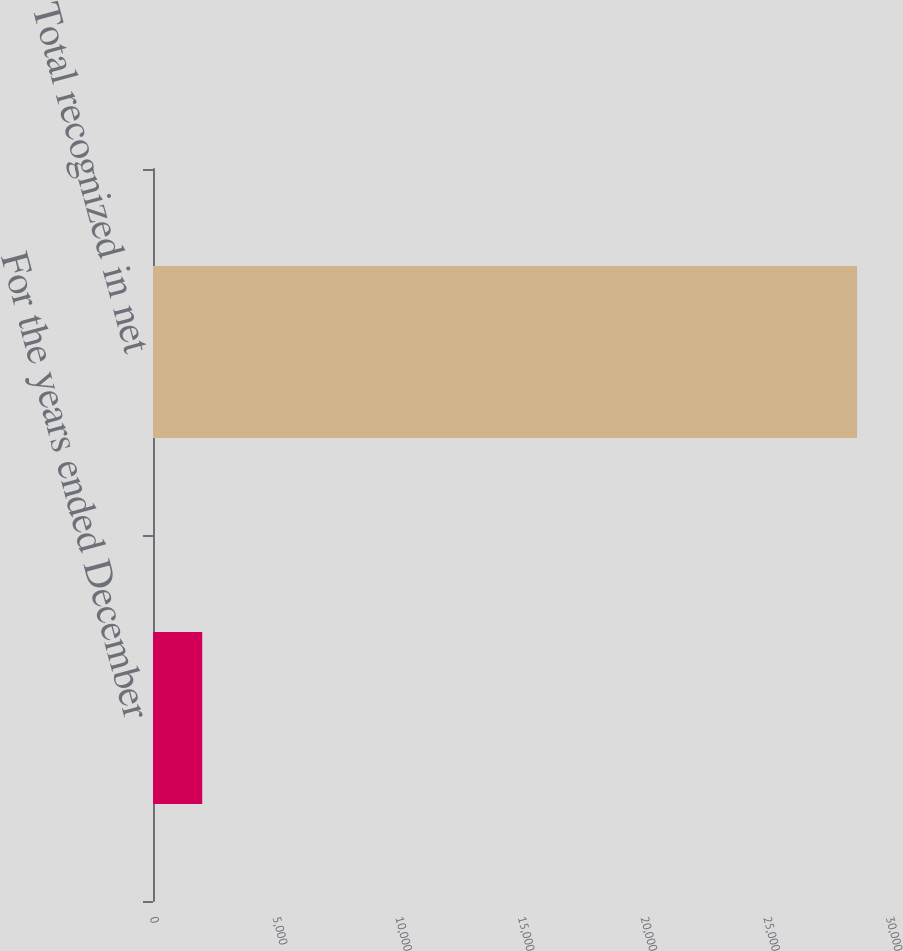<chart> <loc_0><loc_0><loc_500><loc_500><bar_chart><fcel>For the years ended December<fcel>Total recognized in net<nl><fcel>2006<fcel>28698<nl></chart> 